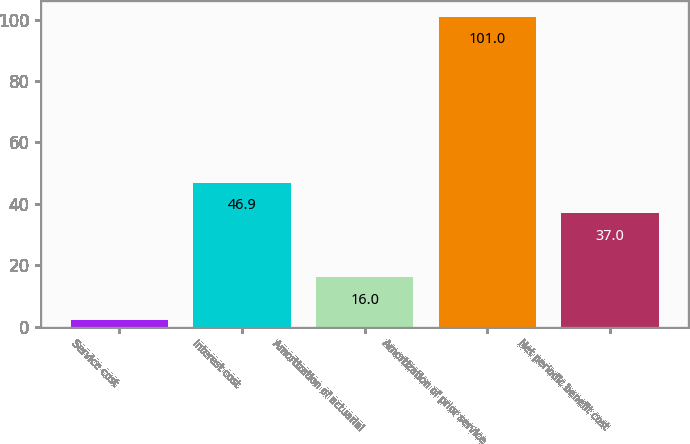Convert chart to OTSL. <chart><loc_0><loc_0><loc_500><loc_500><bar_chart><fcel>Service cost<fcel>Interest cost<fcel>Amortization of actuarial<fcel>Amortization of prior service<fcel>Net periodic benefit cost<nl><fcel>2<fcel>46.9<fcel>16<fcel>101<fcel>37<nl></chart> 